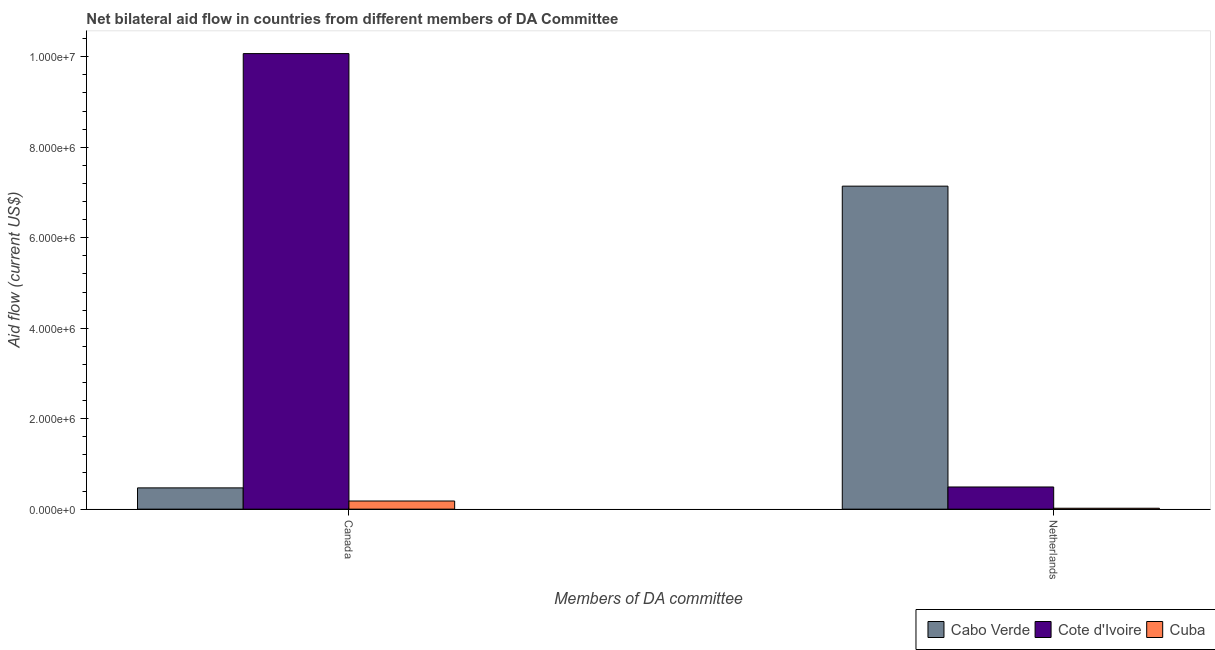Are the number of bars per tick equal to the number of legend labels?
Your answer should be compact. Yes. Are the number of bars on each tick of the X-axis equal?
Your response must be concise. Yes. How many bars are there on the 2nd tick from the left?
Your answer should be compact. 3. How many bars are there on the 2nd tick from the right?
Make the answer very short. 3. What is the label of the 2nd group of bars from the left?
Offer a very short reply. Netherlands. What is the amount of aid given by netherlands in Cuba?
Give a very brief answer. 2.00e+04. Across all countries, what is the maximum amount of aid given by canada?
Provide a succinct answer. 1.01e+07. Across all countries, what is the minimum amount of aid given by canada?
Give a very brief answer. 1.80e+05. In which country was the amount of aid given by netherlands maximum?
Give a very brief answer. Cabo Verde. In which country was the amount of aid given by canada minimum?
Provide a short and direct response. Cuba. What is the total amount of aid given by netherlands in the graph?
Your response must be concise. 7.65e+06. What is the difference between the amount of aid given by netherlands in Cote d'Ivoire and that in Cuba?
Provide a short and direct response. 4.70e+05. What is the difference between the amount of aid given by netherlands in Cote d'Ivoire and the amount of aid given by canada in Cabo Verde?
Give a very brief answer. 2.00e+04. What is the average amount of aid given by netherlands per country?
Keep it short and to the point. 2.55e+06. What is the difference between the amount of aid given by canada and amount of aid given by netherlands in Cuba?
Provide a short and direct response. 1.60e+05. What is the ratio of the amount of aid given by netherlands in Cuba to that in Cote d'Ivoire?
Your response must be concise. 0.04. Is the amount of aid given by netherlands in Cabo Verde less than that in Cote d'Ivoire?
Provide a short and direct response. No. In how many countries, is the amount of aid given by netherlands greater than the average amount of aid given by netherlands taken over all countries?
Offer a terse response. 1. What does the 1st bar from the left in Canada represents?
Ensure brevity in your answer.  Cabo Verde. What does the 1st bar from the right in Netherlands represents?
Provide a short and direct response. Cuba. Are all the bars in the graph horizontal?
Provide a short and direct response. No. How many countries are there in the graph?
Give a very brief answer. 3. Are the values on the major ticks of Y-axis written in scientific E-notation?
Ensure brevity in your answer.  Yes. Does the graph contain any zero values?
Give a very brief answer. No. Does the graph contain grids?
Your answer should be compact. No. What is the title of the graph?
Make the answer very short. Net bilateral aid flow in countries from different members of DA Committee. What is the label or title of the X-axis?
Offer a very short reply. Members of DA committee. What is the Aid flow (current US$) in Cote d'Ivoire in Canada?
Your response must be concise. 1.01e+07. What is the Aid flow (current US$) in Cuba in Canada?
Make the answer very short. 1.80e+05. What is the Aid flow (current US$) in Cabo Verde in Netherlands?
Your response must be concise. 7.14e+06. What is the Aid flow (current US$) in Cote d'Ivoire in Netherlands?
Your response must be concise. 4.90e+05. What is the Aid flow (current US$) of Cuba in Netherlands?
Your response must be concise. 2.00e+04. Across all Members of DA committee, what is the maximum Aid flow (current US$) in Cabo Verde?
Ensure brevity in your answer.  7.14e+06. Across all Members of DA committee, what is the maximum Aid flow (current US$) of Cote d'Ivoire?
Your answer should be very brief. 1.01e+07. What is the total Aid flow (current US$) of Cabo Verde in the graph?
Offer a very short reply. 7.61e+06. What is the total Aid flow (current US$) in Cote d'Ivoire in the graph?
Give a very brief answer. 1.06e+07. What is the total Aid flow (current US$) in Cuba in the graph?
Offer a very short reply. 2.00e+05. What is the difference between the Aid flow (current US$) in Cabo Verde in Canada and that in Netherlands?
Give a very brief answer. -6.67e+06. What is the difference between the Aid flow (current US$) in Cote d'Ivoire in Canada and that in Netherlands?
Offer a terse response. 9.58e+06. What is the difference between the Aid flow (current US$) in Cuba in Canada and that in Netherlands?
Your answer should be compact. 1.60e+05. What is the difference between the Aid flow (current US$) of Cabo Verde in Canada and the Aid flow (current US$) of Cote d'Ivoire in Netherlands?
Provide a short and direct response. -2.00e+04. What is the difference between the Aid flow (current US$) of Cabo Verde in Canada and the Aid flow (current US$) of Cuba in Netherlands?
Provide a short and direct response. 4.50e+05. What is the difference between the Aid flow (current US$) in Cote d'Ivoire in Canada and the Aid flow (current US$) in Cuba in Netherlands?
Ensure brevity in your answer.  1.00e+07. What is the average Aid flow (current US$) in Cabo Verde per Members of DA committee?
Give a very brief answer. 3.80e+06. What is the average Aid flow (current US$) in Cote d'Ivoire per Members of DA committee?
Offer a very short reply. 5.28e+06. What is the average Aid flow (current US$) of Cuba per Members of DA committee?
Offer a very short reply. 1.00e+05. What is the difference between the Aid flow (current US$) of Cabo Verde and Aid flow (current US$) of Cote d'Ivoire in Canada?
Your answer should be very brief. -9.60e+06. What is the difference between the Aid flow (current US$) of Cote d'Ivoire and Aid flow (current US$) of Cuba in Canada?
Your answer should be compact. 9.89e+06. What is the difference between the Aid flow (current US$) in Cabo Verde and Aid flow (current US$) in Cote d'Ivoire in Netherlands?
Offer a very short reply. 6.65e+06. What is the difference between the Aid flow (current US$) of Cabo Verde and Aid flow (current US$) of Cuba in Netherlands?
Give a very brief answer. 7.12e+06. What is the difference between the Aid flow (current US$) of Cote d'Ivoire and Aid flow (current US$) of Cuba in Netherlands?
Provide a succinct answer. 4.70e+05. What is the ratio of the Aid flow (current US$) of Cabo Verde in Canada to that in Netherlands?
Ensure brevity in your answer.  0.07. What is the ratio of the Aid flow (current US$) of Cote d'Ivoire in Canada to that in Netherlands?
Provide a short and direct response. 20.55. What is the ratio of the Aid flow (current US$) in Cuba in Canada to that in Netherlands?
Keep it short and to the point. 9. What is the difference between the highest and the second highest Aid flow (current US$) in Cabo Verde?
Offer a very short reply. 6.67e+06. What is the difference between the highest and the second highest Aid flow (current US$) of Cote d'Ivoire?
Provide a succinct answer. 9.58e+06. What is the difference between the highest and the second highest Aid flow (current US$) of Cuba?
Offer a very short reply. 1.60e+05. What is the difference between the highest and the lowest Aid flow (current US$) of Cabo Verde?
Give a very brief answer. 6.67e+06. What is the difference between the highest and the lowest Aid flow (current US$) in Cote d'Ivoire?
Your answer should be compact. 9.58e+06. 